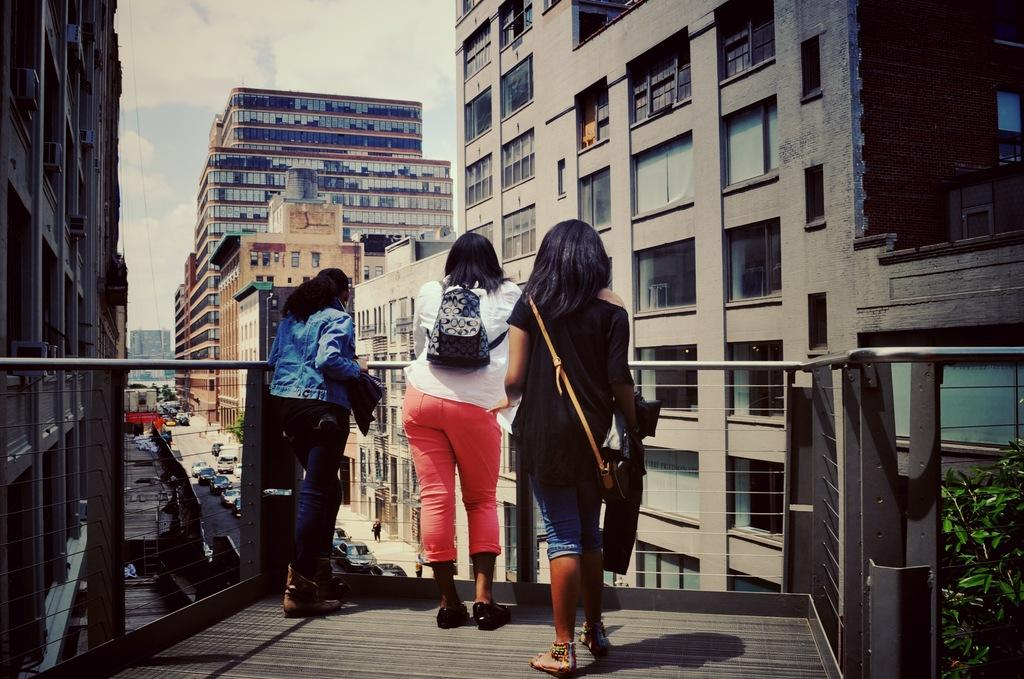What can be seen in the foreground of the image? There are persons standing in the front of the image. What is visible in the background of the image? There are buildings and cars on the road in the background of the image. What type of vegetation is present on the right side of the image? There are leaves on the right side of the image. How would you describe the weather in the image? The sky is cloudy in the image. Can you tell me how many muscles are flexed by the persons in the image? There is no information about the muscles of the persons in the image, so it cannot be determined. What type of horse can be seen grazing on the left side of the image? There is no horse present in the image; it features persons, buildings, cars, leaves, and a cloudy sky. 